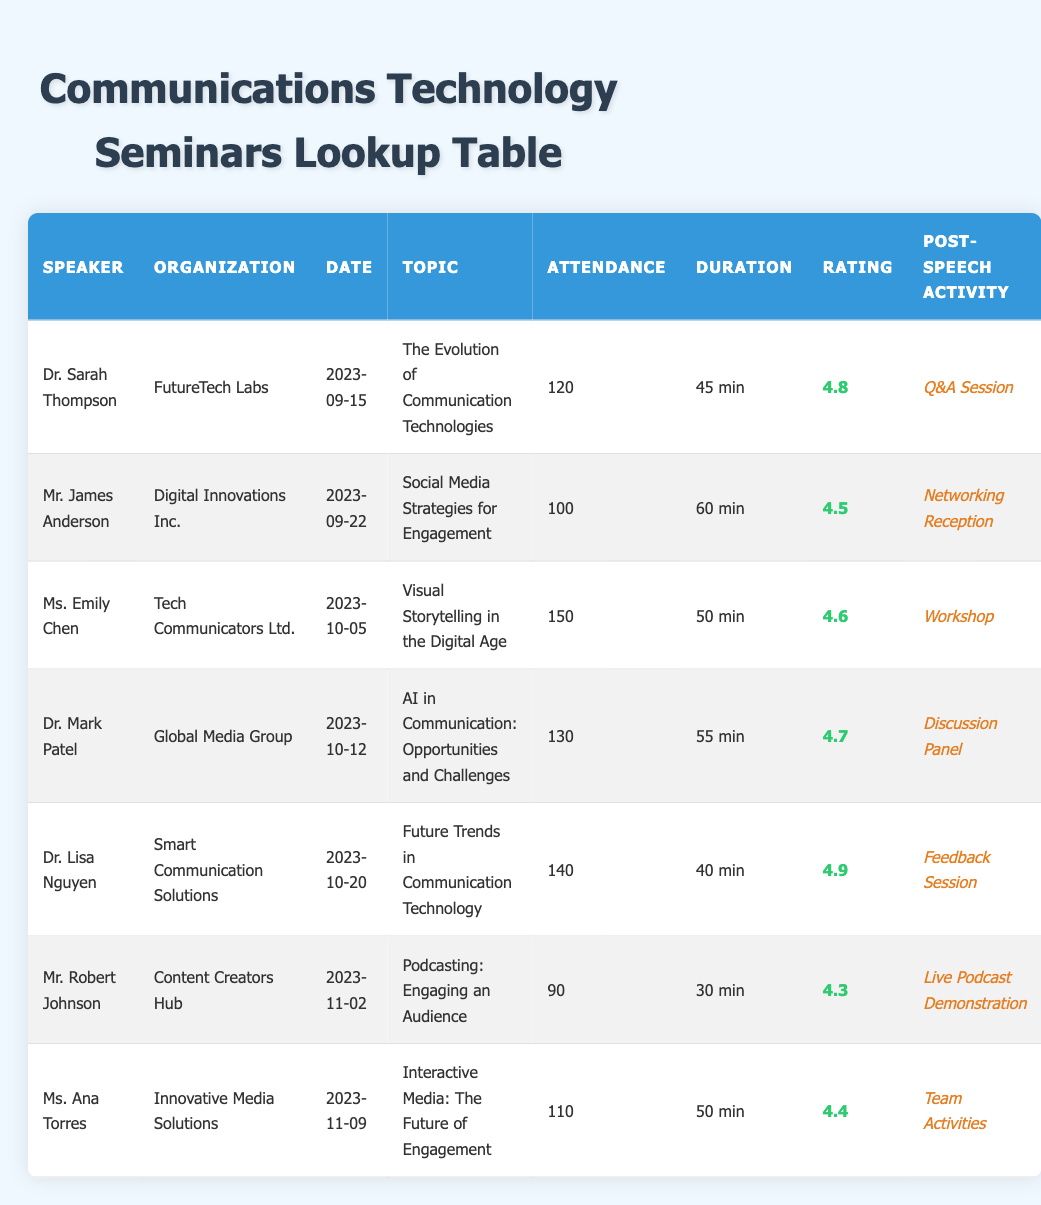What is the attendance count for Dr. Sarah Thompson's speech? The attendance count for Dr. Sarah Thompson's speech is shown in the row corresponding to her name in the table. It lists 120 attendees for her speech on "The Evolution of Communication Technologies."
Answer: 120 Who delivered the speech on "Visual Storytelling in the Digital Age"? Ms. Emily Chen is listed in the table as the speaker who delivered the speech on "Visual Storytelling in the Digital Age" on October 5, 2023.
Answer: Ms. Emily Chen What was the highest feedback rating among the speakers? By examining the "Rating" column, Dr. Lisa Nguyen has the highest feedback rating listed at 4.9.
Answer: 4.9 Which speaker had the least attendance, and what was the count? Looking through the "Attendance" column, Mr. Robert Johnson had the least attendance with 90 attendees for his speech on podcasting.
Answer: Mr. Robert Johnson, 90 What is the average duration of all speeches given by the speakers? To find the average duration, we first convert all durations into minutes: 45 + 60 + 50 + 55 + 40 + 30 + 50 = 330 minutes. There are 7 speeches, so the average duration is 330 / 7 = 47.14 minutes.
Answer: 47.14 minutes Did any speaker have an attendance count of over 130? By checking the "Attendance" column, we can see that there are speakers with attendance counts of 150 (Ms. Emily Chen), 140 (Dr. Lisa Nguyen), and 130 (Dr. Mark Patel). Therefore, the answer is yes.
Answer: Yes Which post-speech activity had the most number of attendees of the related speaker? From the table, Ms. Emily Chen's workshop had the highest attendance of 150 attendees, which is the largest figure in the "Attendance" column for related activities.
Answer: Workshop, 150 How many speakers had feedback ratings of 4.5 or higher? Counting the speakers with feedback ratings listed: Dr. Sarah Thompson (4.8), Mr. James Anderson (4.5), Ms. Emily Chen (4.6), Dr. Mark Patel (4.7), Dr. Lisa Nguyen (4.9), Mr. Robert Johnson (4.3 does not count), and Ms. Ana Torres (4.4), we find there are 6 speakers with ratings of 4.5 or higher.
Answer: 6 speakers Which speaker's topic included the term "Future"? By scanning the "Topic" column, we find Dr. Lisa Nguyen's topic "Future Trends in Communication Technology" includes the term "Future."
Answer: Dr. Lisa Nguyen 